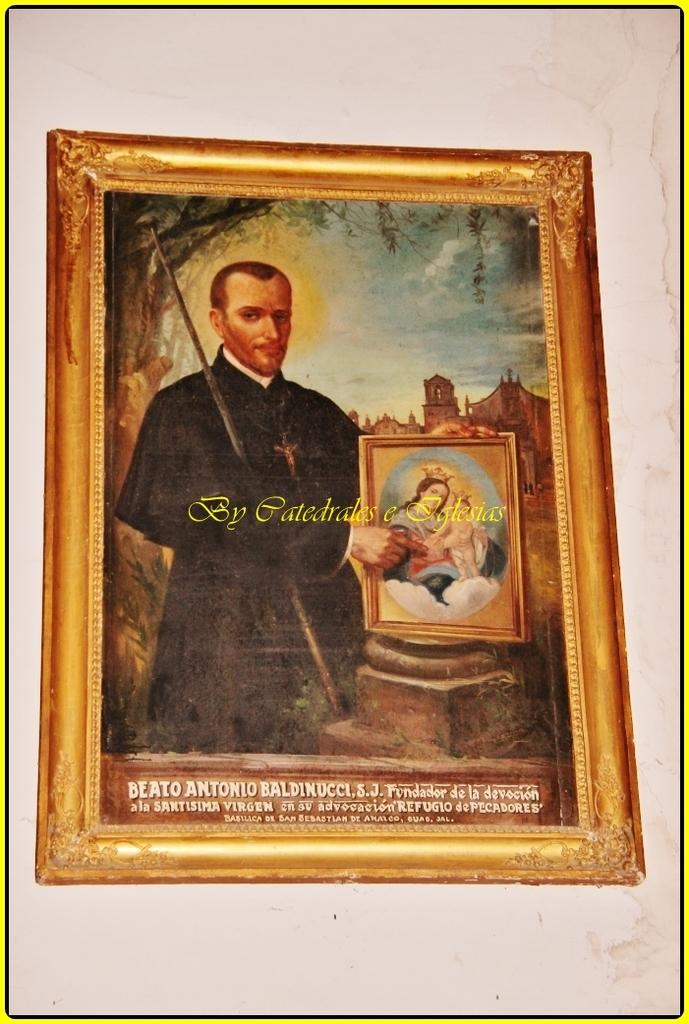<image>
Summarize the visual content of the image. The word Beato is visible on a picture of a man holding a stick. 